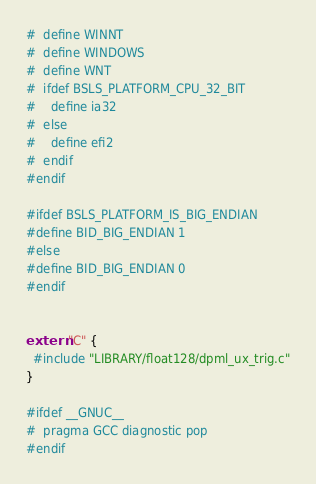<code> <loc_0><loc_0><loc_500><loc_500><_C++_>#  define WINNT
#  define WINDOWS
#  define WNT
#  ifdef BSLS_PLATFORM_CPU_32_BIT
#    define ia32
#  else
#    define efi2
#  endif
#endif

#ifdef BSLS_PLATFORM_IS_BIG_ENDIAN
#define BID_BIG_ENDIAN 1
#else
#define BID_BIG_ENDIAN 0
#endif


extern "C" {
  #include "LIBRARY/float128/dpml_ux_trig.c"
}

#ifdef __GNUC__
#  pragma GCC diagnostic pop
#endif
</code> 